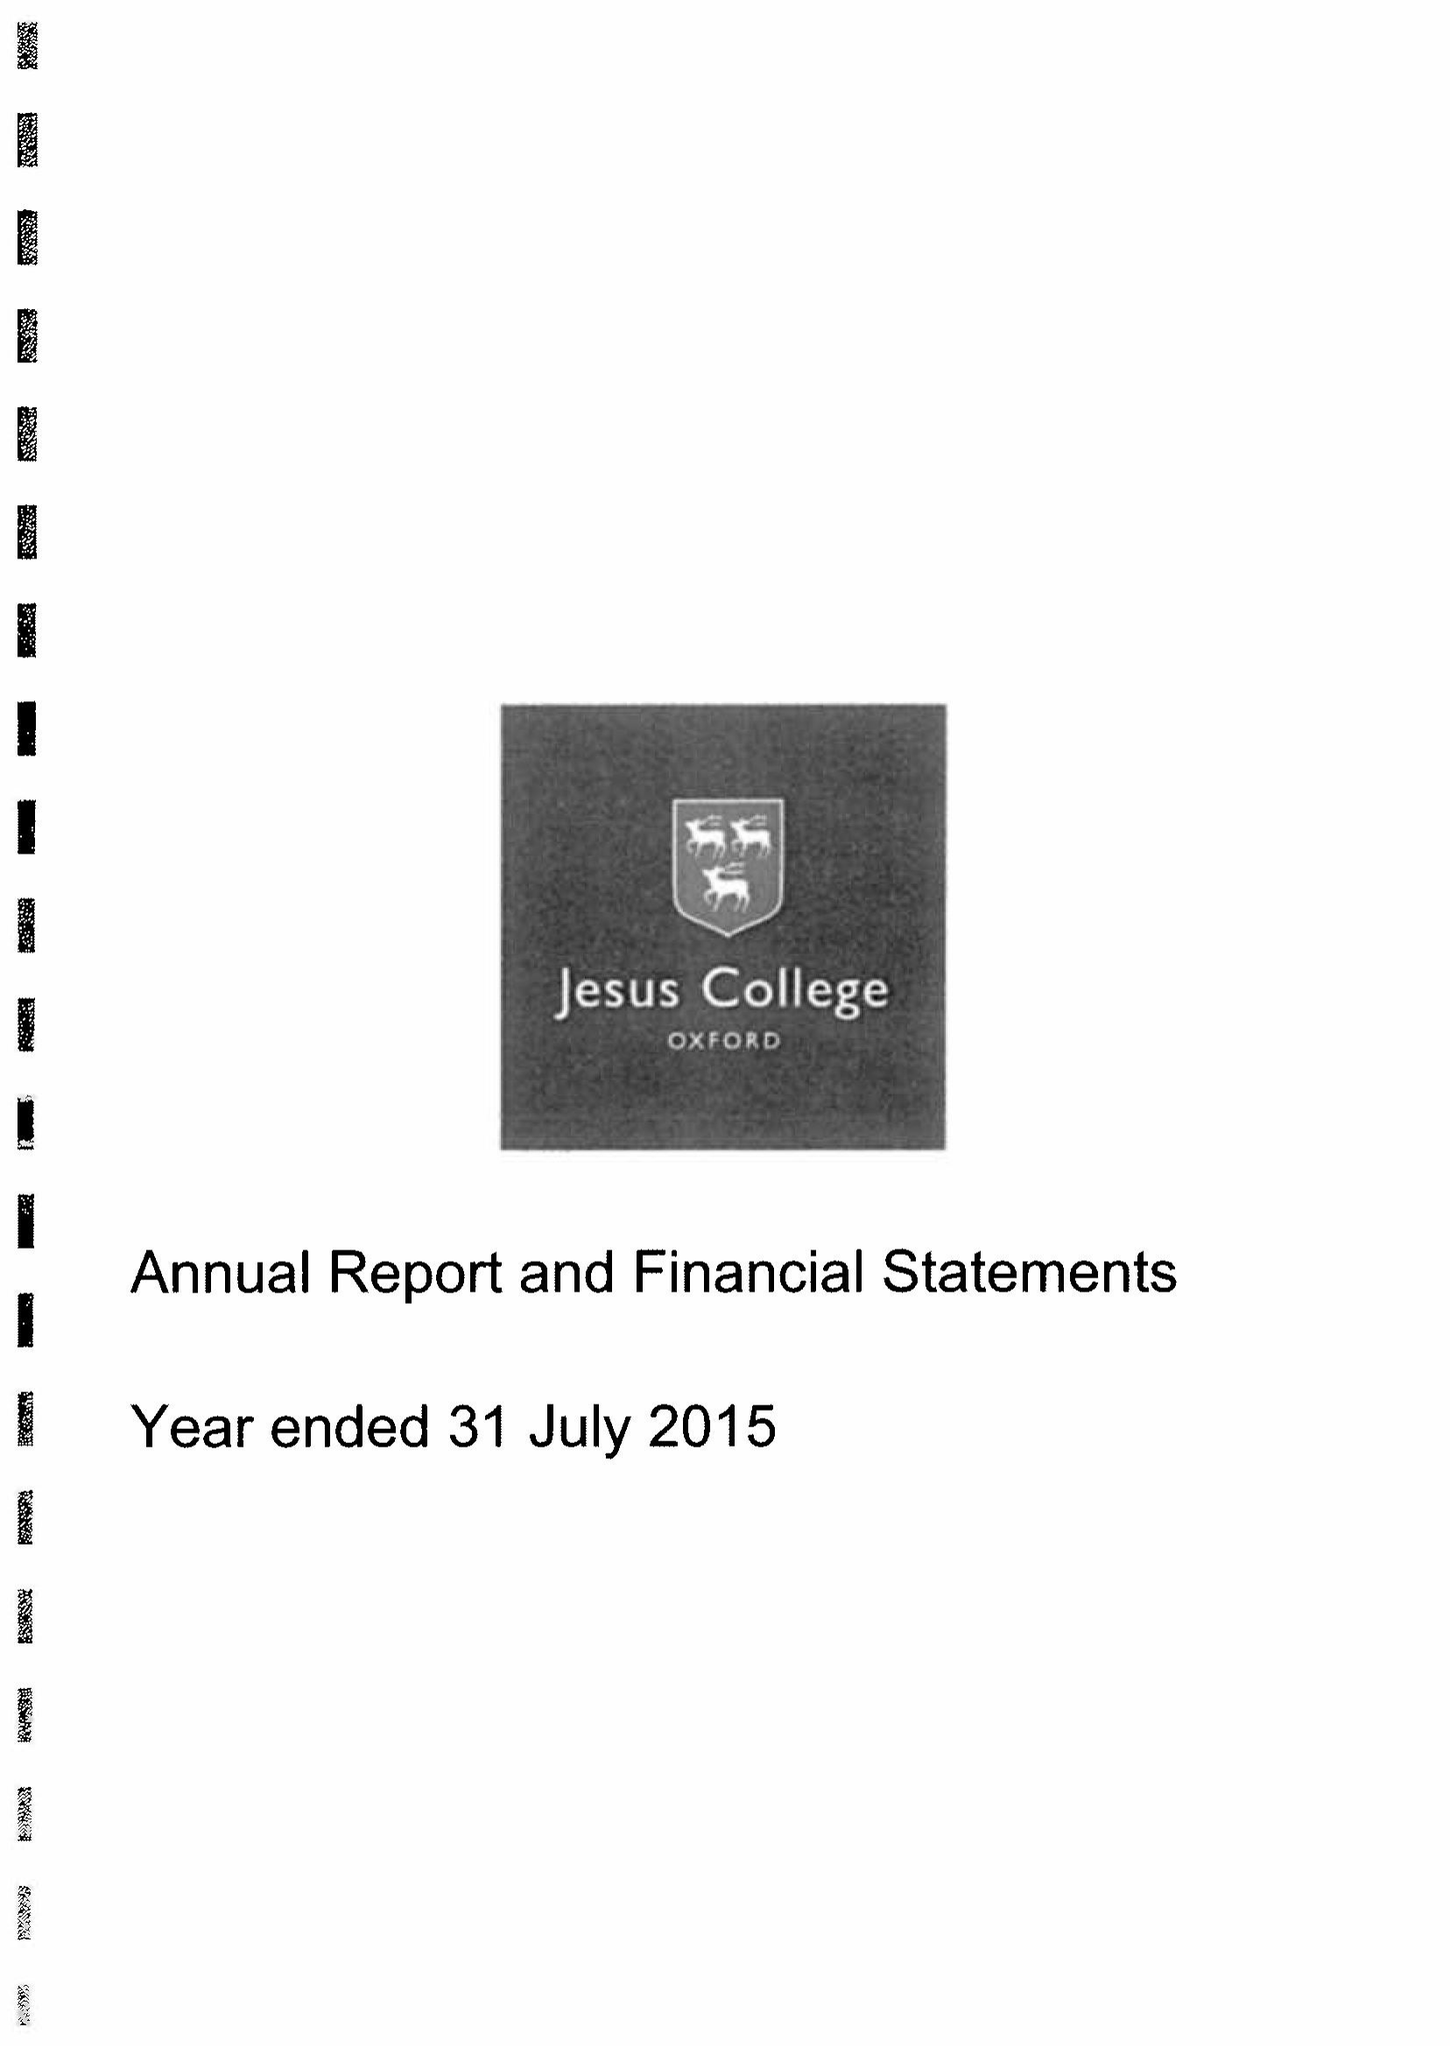What is the value for the address__postcode?
Answer the question using a single word or phrase. OX1 3DW 